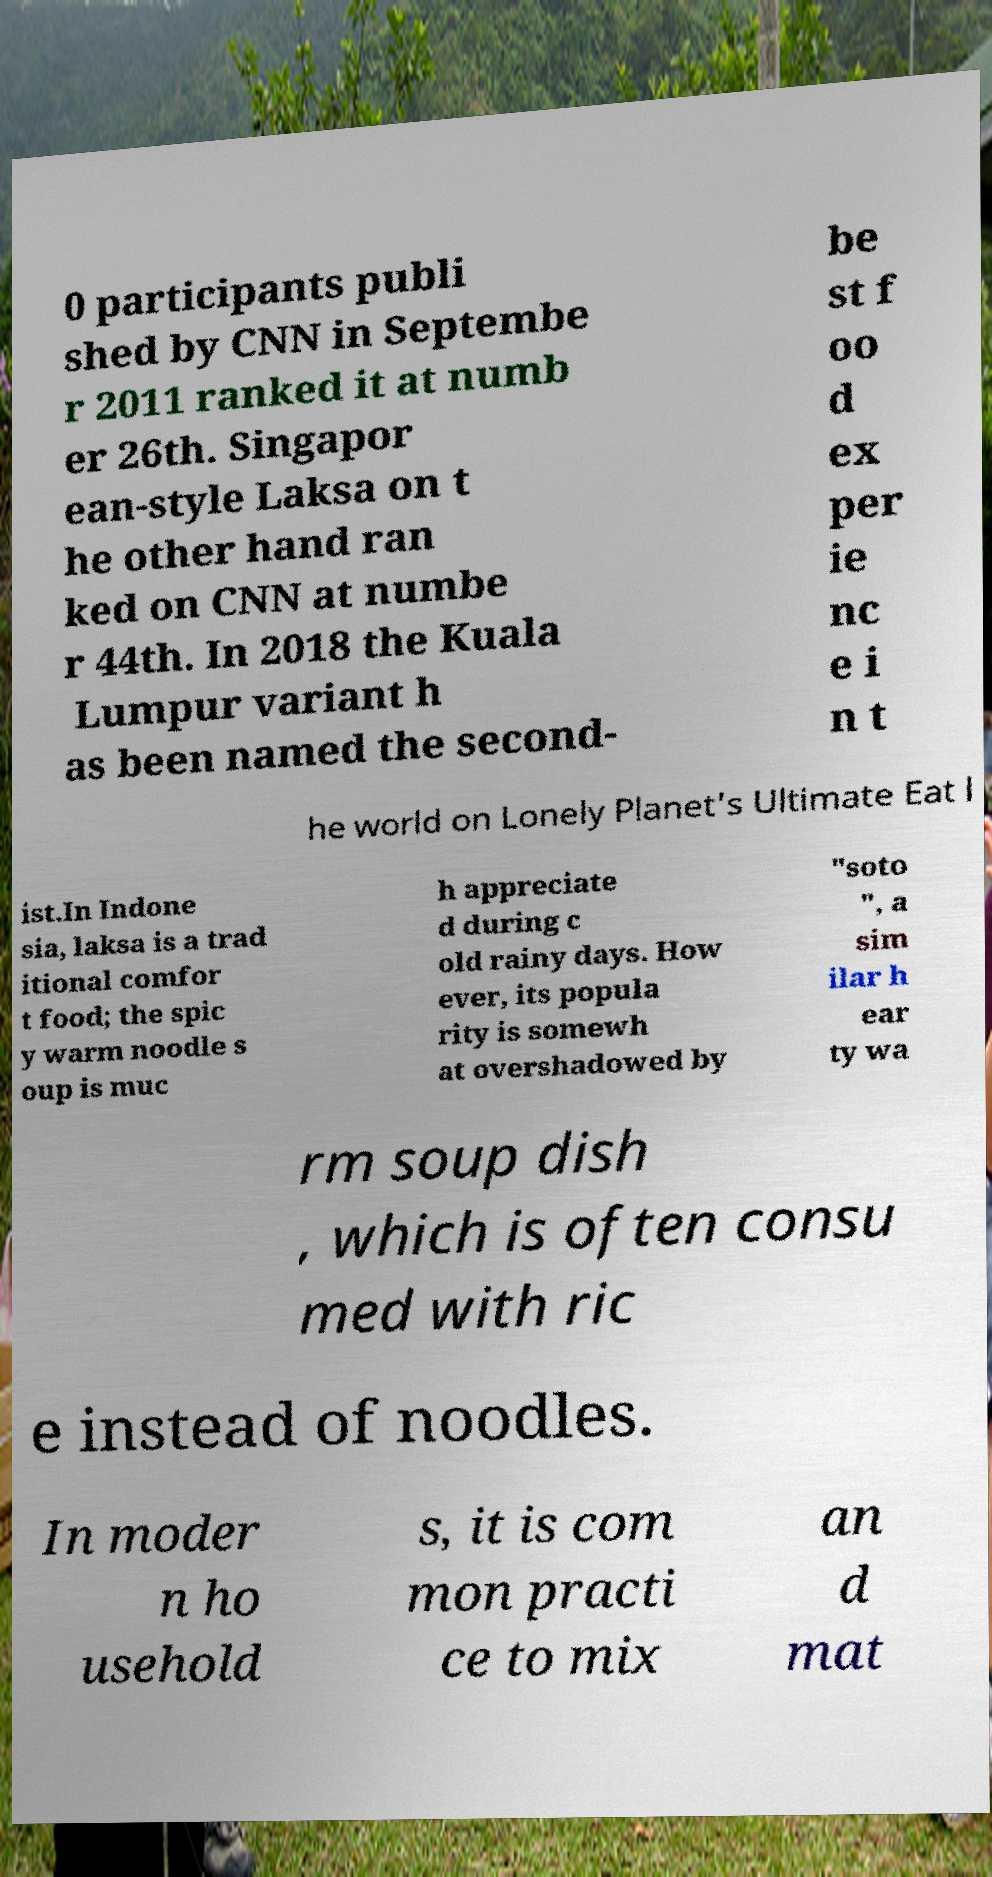Please read and relay the text visible in this image. What does it say? 0 participants publi shed by CNN in Septembe r 2011 ranked it at numb er 26th. Singapor ean-style Laksa on t he other hand ran ked on CNN at numbe r 44th. In 2018 the Kuala Lumpur variant h as been named the second- be st f oo d ex per ie nc e i n t he world on Lonely Planet's Ultimate Eat l ist.In Indone sia, laksa is a trad itional comfor t food; the spic y warm noodle s oup is muc h appreciate d during c old rainy days. How ever, its popula rity is somewh at overshadowed by "soto ", a sim ilar h ear ty wa rm soup dish , which is often consu med with ric e instead of noodles. In moder n ho usehold s, it is com mon practi ce to mix an d mat 